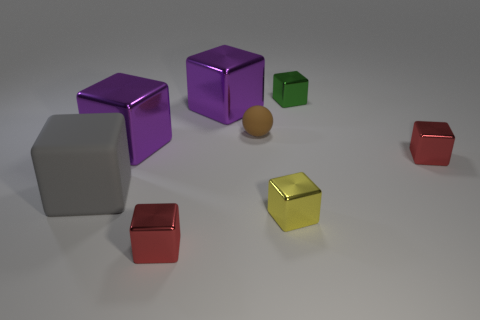How many balls are in front of the small cube that is behind the large purple metallic cube that is in front of the tiny brown sphere?
Your response must be concise. 1. What is the shape of the small yellow thing that is the same material as the green thing?
Provide a short and direct response. Cube. There is a small red cube that is left of the small red object that is behind the tiny shiny object that is in front of the tiny yellow metallic cube; what is it made of?
Keep it short and to the point. Metal. What number of objects are either small red blocks in front of the yellow metallic block or green metal blocks?
Ensure brevity in your answer.  2. What number of other objects are the same shape as the tiny green shiny object?
Provide a succinct answer. 6. Is the number of tiny yellow metallic things that are on the left side of the rubber block greater than the number of tiny rubber objects?
Make the answer very short. No. There is a gray thing that is the same shape as the green metal object; what is its size?
Offer a very short reply. Large. Are there any other things that are made of the same material as the yellow thing?
Offer a very short reply. Yes. The brown thing has what shape?
Your answer should be very brief. Sphere. There is a brown object that is the same size as the green metal object; what is its shape?
Provide a succinct answer. Sphere. 